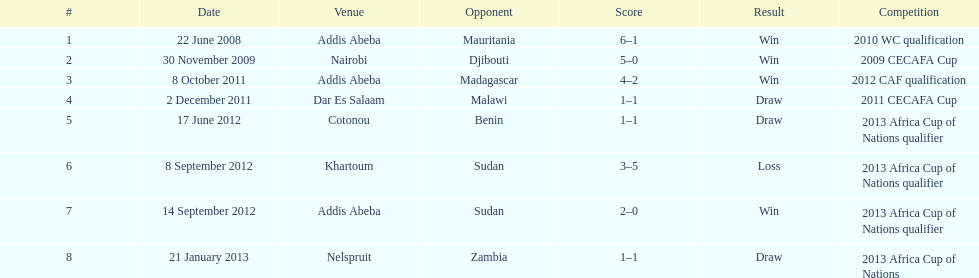What date gives was their only loss? 8 September 2012. 